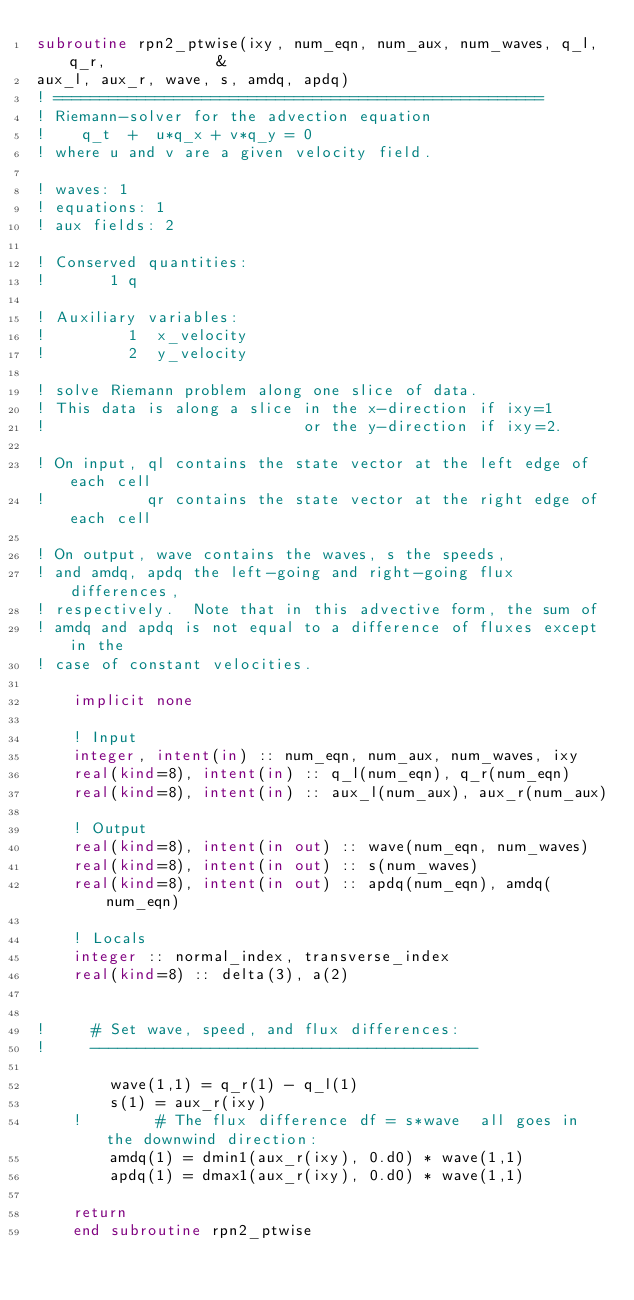<code> <loc_0><loc_0><loc_500><loc_500><_FORTRAN_>subroutine rpn2_ptwise(ixy, num_eqn, num_aux, num_waves, q_l, q_r,            &
aux_l, aux_r, wave, s, amdq, apdq)
! =====================================================
! Riemann-solver for the advection equation
!    q_t  +  u*q_x + v*q_y = 0
! where u and v are a given velocity field.

! waves: 1
! equations: 1
! aux fields: 2

! Conserved quantities:
!       1 q

! Auxiliary variables:
!         1  x_velocity
!         2  y_velocity

! solve Riemann problem along one slice of data.
! This data is along a slice in the x-direction if ixy=1
!                            or the y-direction if ixy=2.

! On input, ql contains the state vector at the left edge of each cell
!           qr contains the state vector at the right edge of each cell

! On output, wave contains the waves, s the speeds,
! and amdq, apdq the left-going and right-going flux differences,
! respectively.  Note that in this advective form, the sum of
! amdq and apdq is not equal to a difference of fluxes except in the
! case of constant velocities.

    implicit none

    ! Input
    integer, intent(in) :: num_eqn, num_aux, num_waves, ixy
    real(kind=8), intent(in) :: q_l(num_eqn), q_r(num_eqn)
    real(kind=8), intent(in) :: aux_l(num_aux), aux_r(num_aux)

    ! Output
    real(kind=8), intent(in out) :: wave(num_eqn, num_waves)
    real(kind=8), intent(in out) :: s(num_waves)
    real(kind=8), intent(in out) :: apdq(num_eqn), amdq(num_eqn)

    ! Locals
    integer :: normal_index, transverse_index
    real(kind=8) :: delta(3), a(2)


!     # Set wave, speed, and flux differences:
!     ------------------------------------------

        wave(1,1) = q_r(1) - q_l(1)
        s(1) = aux_r(ixy)
    !        # The flux difference df = s*wave  all goes in the downwind direction:
        amdq(1) = dmin1(aux_r(ixy), 0.d0) * wave(1,1)
        apdq(1) = dmax1(aux_r(ixy), 0.d0) * wave(1,1)

    return
    end subroutine rpn2_ptwise
</code> 